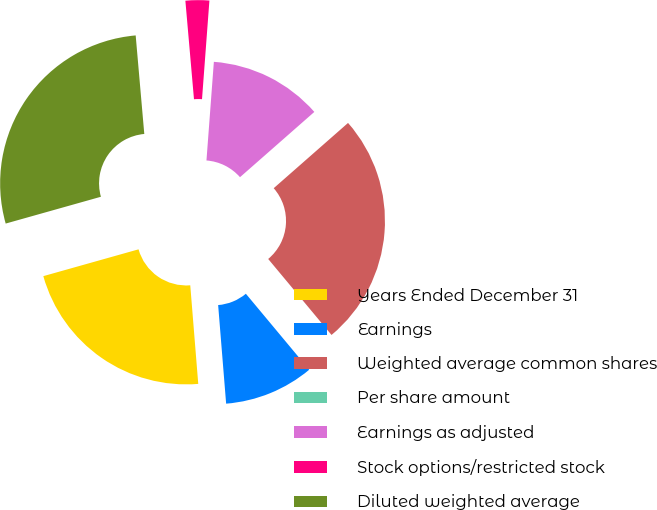Convert chart. <chart><loc_0><loc_0><loc_500><loc_500><pie_chart><fcel>Years Ended December 31<fcel>Earnings<fcel>Weighted average common shares<fcel>Per share amount<fcel>Earnings as adjusted<fcel>Stock options/restricted stock<fcel>Diluted weighted average<nl><fcel>21.92%<fcel>9.77%<fcel>25.41%<fcel>0.0%<fcel>12.34%<fcel>2.58%<fcel>27.98%<nl></chart> 